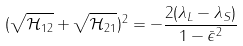Convert formula to latex. <formula><loc_0><loc_0><loc_500><loc_500>( \sqrt { \mathcal { H } _ { 1 2 } } + \sqrt { \mathcal { H } _ { 2 1 } } ) ^ { 2 } = - \frac { 2 ( \lambda _ { L } - \lambda _ { S } ) } { 1 - \bar { \epsilon } ^ { 2 } }</formula> 